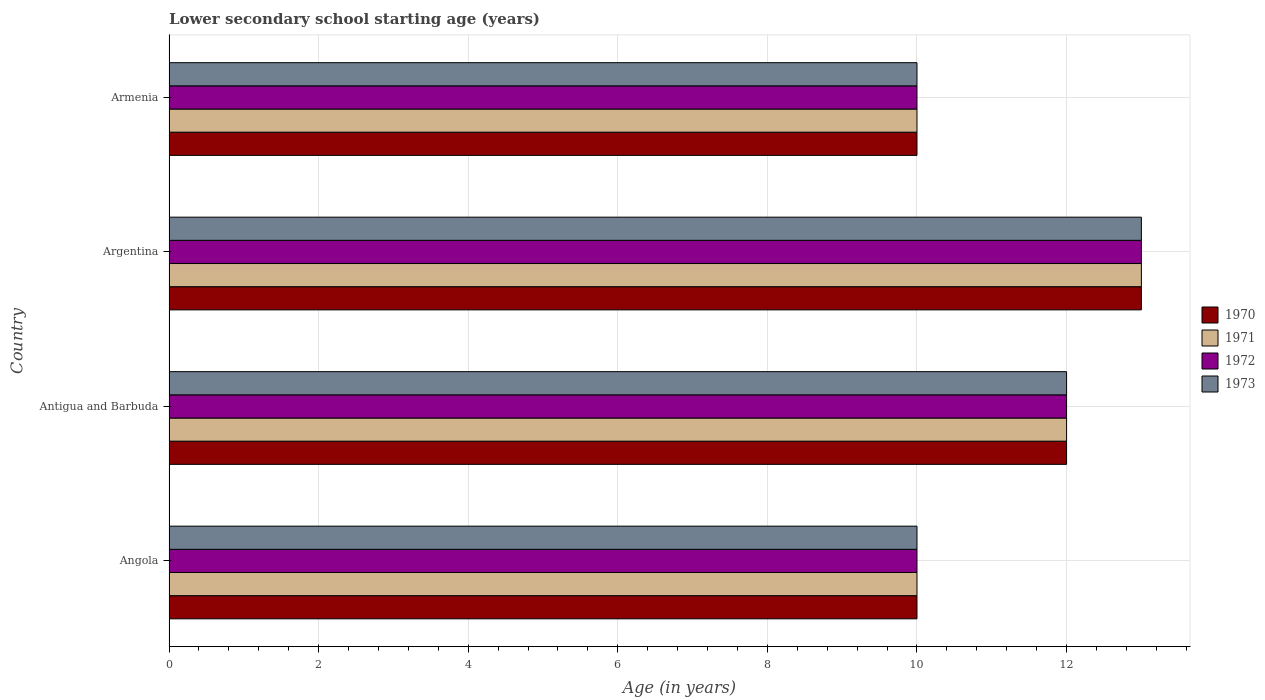How many different coloured bars are there?
Your answer should be compact. 4. How many groups of bars are there?
Provide a succinct answer. 4. Are the number of bars per tick equal to the number of legend labels?
Give a very brief answer. Yes. Are the number of bars on each tick of the Y-axis equal?
Provide a succinct answer. Yes. How many bars are there on the 1st tick from the top?
Ensure brevity in your answer.  4. What is the label of the 4th group of bars from the top?
Make the answer very short. Angola. In how many cases, is the number of bars for a given country not equal to the number of legend labels?
Provide a short and direct response. 0. What is the lower secondary school starting age of children in 1971 in Angola?
Your answer should be compact. 10. In which country was the lower secondary school starting age of children in 1971 maximum?
Your answer should be compact. Argentina. In which country was the lower secondary school starting age of children in 1972 minimum?
Make the answer very short. Angola. What is the difference between the lower secondary school starting age of children in 1970 in Angola and that in Armenia?
Provide a short and direct response. 0. What is the difference between the lower secondary school starting age of children in 1970 in Argentina and the lower secondary school starting age of children in 1973 in Armenia?
Your answer should be compact. 3. What is the average lower secondary school starting age of children in 1970 per country?
Provide a short and direct response. 11.25. Is the lower secondary school starting age of children in 1970 in Angola less than that in Argentina?
Give a very brief answer. Yes. What is the difference between the highest and the second highest lower secondary school starting age of children in 1972?
Your response must be concise. 1. Is the sum of the lower secondary school starting age of children in 1973 in Angola and Armenia greater than the maximum lower secondary school starting age of children in 1970 across all countries?
Offer a very short reply. Yes. Is it the case that in every country, the sum of the lower secondary school starting age of children in 1971 and lower secondary school starting age of children in 1973 is greater than the sum of lower secondary school starting age of children in 1970 and lower secondary school starting age of children in 1972?
Offer a terse response. No. Is it the case that in every country, the sum of the lower secondary school starting age of children in 1971 and lower secondary school starting age of children in 1972 is greater than the lower secondary school starting age of children in 1970?
Offer a very short reply. Yes. Are all the bars in the graph horizontal?
Make the answer very short. Yes. What is the difference between two consecutive major ticks on the X-axis?
Provide a short and direct response. 2. Does the graph contain grids?
Offer a very short reply. Yes. Where does the legend appear in the graph?
Your answer should be compact. Center right. How many legend labels are there?
Provide a succinct answer. 4. How are the legend labels stacked?
Offer a very short reply. Vertical. What is the title of the graph?
Your answer should be compact. Lower secondary school starting age (years). Does "1985" appear as one of the legend labels in the graph?
Ensure brevity in your answer.  No. What is the label or title of the X-axis?
Give a very brief answer. Age (in years). What is the Age (in years) in 1970 in Angola?
Keep it short and to the point. 10. What is the Age (in years) of 1971 in Angola?
Make the answer very short. 10. What is the Age (in years) in 1973 in Angola?
Provide a succinct answer. 10. What is the Age (in years) in 1970 in Antigua and Barbuda?
Provide a succinct answer. 12. What is the Age (in years) of 1971 in Antigua and Barbuda?
Your answer should be very brief. 12. What is the Age (in years) of 1972 in Antigua and Barbuda?
Keep it short and to the point. 12. What is the Age (in years) of 1973 in Argentina?
Keep it short and to the point. 13. Across all countries, what is the maximum Age (in years) in 1970?
Offer a very short reply. 13. Across all countries, what is the maximum Age (in years) in 1972?
Offer a very short reply. 13. Across all countries, what is the maximum Age (in years) in 1973?
Give a very brief answer. 13. Across all countries, what is the minimum Age (in years) in 1971?
Your response must be concise. 10. Across all countries, what is the minimum Age (in years) of 1972?
Your answer should be compact. 10. Across all countries, what is the minimum Age (in years) in 1973?
Provide a succinct answer. 10. What is the difference between the Age (in years) of 1970 in Angola and that in Antigua and Barbuda?
Make the answer very short. -2. What is the difference between the Age (in years) in 1972 in Angola and that in Antigua and Barbuda?
Your response must be concise. -2. What is the difference between the Age (in years) in 1971 in Angola and that in Argentina?
Keep it short and to the point. -3. What is the difference between the Age (in years) of 1971 in Angola and that in Armenia?
Make the answer very short. 0. What is the difference between the Age (in years) in 1972 in Angola and that in Armenia?
Offer a terse response. 0. What is the difference between the Age (in years) in 1973 in Angola and that in Armenia?
Your response must be concise. 0. What is the difference between the Age (in years) of 1970 in Antigua and Barbuda and that in Argentina?
Make the answer very short. -1. What is the difference between the Age (in years) of 1972 in Antigua and Barbuda and that in Argentina?
Ensure brevity in your answer.  -1. What is the difference between the Age (in years) in 1972 in Antigua and Barbuda and that in Armenia?
Your answer should be very brief. 2. What is the difference between the Age (in years) in 1973 in Antigua and Barbuda and that in Armenia?
Provide a short and direct response. 2. What is the difference between the Age (in years) in 1970 in Argentina and that in Armenia?
Your answer should be very brief. 3. What is the difference between the Age (in years) in 1970 in Angola and the Age (in years) in 1971 in Argentina?
Provide a succinct answer. -3. What is the difference between the Age (in years) of 1970 in Angola and the Age (in years) of 1973 in Argentina?
Your answer should be compact. -3. What is the difference between the Age (in years) of 1971 in Angola and the Age (in years) of 1972 in Argentina?
Your response must be concise. -3. What is the difference between the Age (in years) in 1971 in Angola and the Age (in years) in 1973 in Argentina?
Provide a succinct answer. -3. What is the difference between the Age (in years) in 1970 in Angola and the Age (in years) in 1971 in Armenia?
Your response must be concise. 0. What is the difference between the Age (in years) in 1970 in Angola and the Age (in years) in 1973 in Armenia?
Offer a terse response. 0. What is the difference between the Age (in years) of 1971 in Angola and the Age (in years) of 1973 in Armenia?
Make the answer very short. 0. What is the difference between the Age (in years) of 1970 in Antigua and Barbuda and the Age (in years) of 1971 in Argentina?
Offer a very short reply. -1. What is the difference between the Age (in years) of 1970 in Antigua and Barbuda and the Age (in years) of 1972 in Argentina?
Your response must be concise. -1. What is the difference between the Age (in years) in 1970 in Antigua and Barbuda and the Age (in years) in 1973 in Argentina?
Offer a terse response. -1. What is the difference between the Age (in years) of 1971 in Antigua and Barbuda and the Age (in years) of 1972 in Argentina?
Provide a short and direct response. -1. What is the difference between the Age (in years) of 1970 in Antigua and Barbuda and the Age (in years) of 1971 in Armenia?
Ensure brevity in your answer.  2. What is the difference between the Age (in years) in 1970 in Antigua and Barbuda and the Age (in years) in 1973 in Armenia?
Your response must be concise. 2. What is the difference between the Age (in years) in 1971 in Antigua and Barbuda and the Age (in years) in 1972 in Armenia?
Give a very brief answer. 2. What is the difference between the Age (in years) of 1972 in Antigua and Barbuda and the Age (in years) of 1973 in Armenia?
Your answer should be compact. 2. What is the difference between the Age (in years) in 1970 in Argentina and the Age (in years) in 1973 in Armenia?
Keep it short and to the point. 3. What is the difference between the Age (in years) of 1971 in Argentina and the Age (in years) of 1973 in Armenia?
Offer a terse response. 3. What is the average Age (in years) of 1970 per country?
Offer a very short reply. 11.25. What is the average Age (in years) in 1971 per country?
Provide a succinct answer. 11.25. What is the average Age (in years) in 1972 per country?
Provide a succinct answer. 11.25. What is the average Age (in years) in 1973 per country?
Offer a terse response. 11.25. What is the difference between the Age (in years) of 1970 and Age (in years) of 1971 in Angola?
Your answer should be compact. 0. What is the difference between the Age (in years) of 1971 and Age (in years) of 1972 in Antigua and Barbuda?
Your response must be concise. 0. What is the difference between the Age (in years) in 1971 and Age (in years) in 1973 in Antigua and Barbuda?
Provide a succinct answer. 0. What is the difference between the Age (in years) in 1972 and Age (in years) in 1973 in Antigua and Barbuda?
Your answer should be very brief. 0. What is the difference between the Age (in years) in 1970 and Age (in years) in 1972 in Armenia?
Your response must be concise. 0. What is the difference between the Age (in years) in 1971 and Age (in years) in 1972 in Armenia?
Give a very brief answer. 0. What is the difference between the Age (in years) in 1971 and Age (in years) in 1973 in Armenia?
Make the answer very short. 0. What is the ratio of the Age (in years) of 1970 in Angola to that in Antigua and Barbuda?
Your answer should be very brief. 0.83. What is the ratio of the Age (in years) of 1971 in Angola to that in Antigua and Barbuda?
Your answer should be very brief. 0.83. What is the ratio of the Age (in years) in 1972 in Angola to that in Antigua and Barbuda?
Your answer should be very brief. 0.83. What is the ratio of the Age (in years) of 1973 in Angola to that in Antigua and Barbuda?
Your response must be concise. 0.83. What is the ratio of the Age (in years) of 1970 in Angola to that in Argentina?
Your response must be concise. 0.77. What is the ratio of the Age (in years) of 1971 in Angola to that in Argentina?
Ensure brevity in your answer.  0.77. What is the ratio of the Age (in years) of 1972 in Angola to that in Argentina?
Your answer should be compact. 0.77. What is the ratio of the Age (in years) in 1973 in Angola to that in Argentina?
Your response must be concise. 0.77. What is the ratio of the Age (in years) of 1973 in Angola to that in Armenia?
Offer a very short reply. 1. What is the ratio of the Age (in years) of 1971 in Antigua and Barbuda to that in Argentina?
Offer a very short reply. 0.92. What is the ratio of the Age (in years) of 1972 in Antigua and Barbuda to that in Argentina?
Keep it short and to the point. 0.92. What is the ratio of the Age (in years) of 1973 in Antigua and Barbuda to that in Argentina?
Provide a succinct answer. 0.92. What is the ratio of the Age (in years) in 1973 in Antigua and Barbuda to that in Armenia?
Ensure brevity in your answer.  1.2. What is the difference between the highest and the second highest Age (in years) in 1970?
Provide a short and direct response. 1. What is the difference between the highest and the second highest Age (in years) of 1972?
Give a very brief answer. 1. What is the difference between the highest and the lowest Age (in years) of 1971?
Your answer should be compact. 3. What is the difference between the highest and the lowest Age (in years) of 1972?
Your response must be concise. 3. 